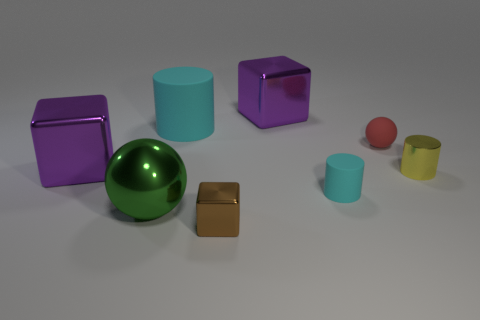What time of day does the lighting in the scene suggest? The lighting in the scene doesn't necessarily suggest a specific time of day as it is a studio lighting setup, with diffused, soft light coming from above, simulating an indoor environment without any direct indicators of natural daylight or nighttime. 